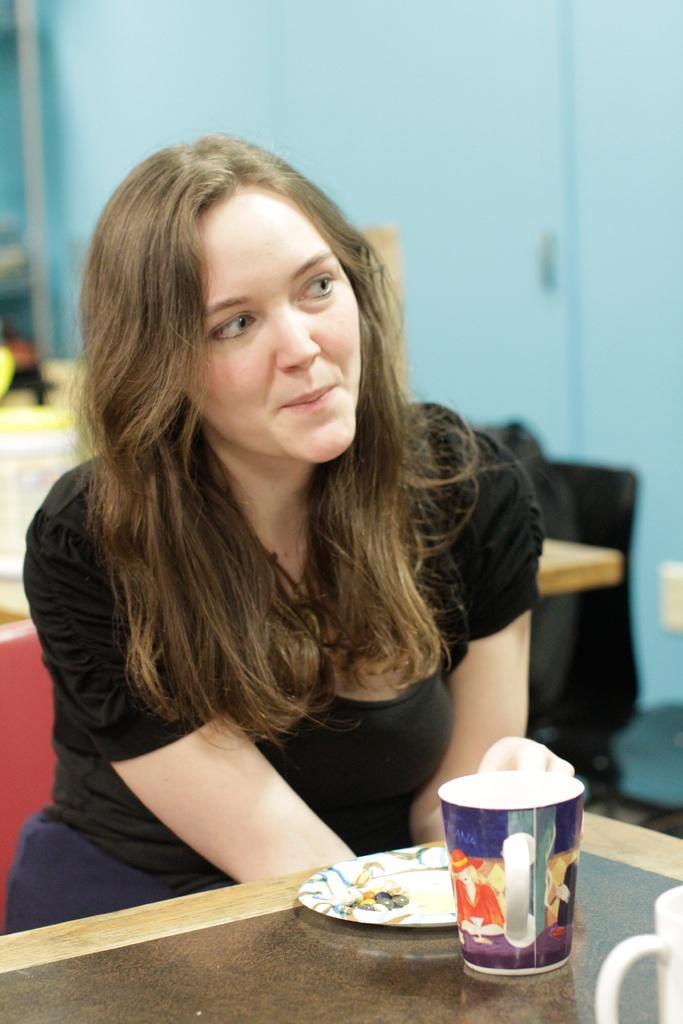In one or two sentences, can you explain what this image depicts? In this image, There is a table which is in yellow color on that table there is a glass and there is a plate, In the middle there is a woman sitting and she is smiling and in the background there is a blue color wall. 